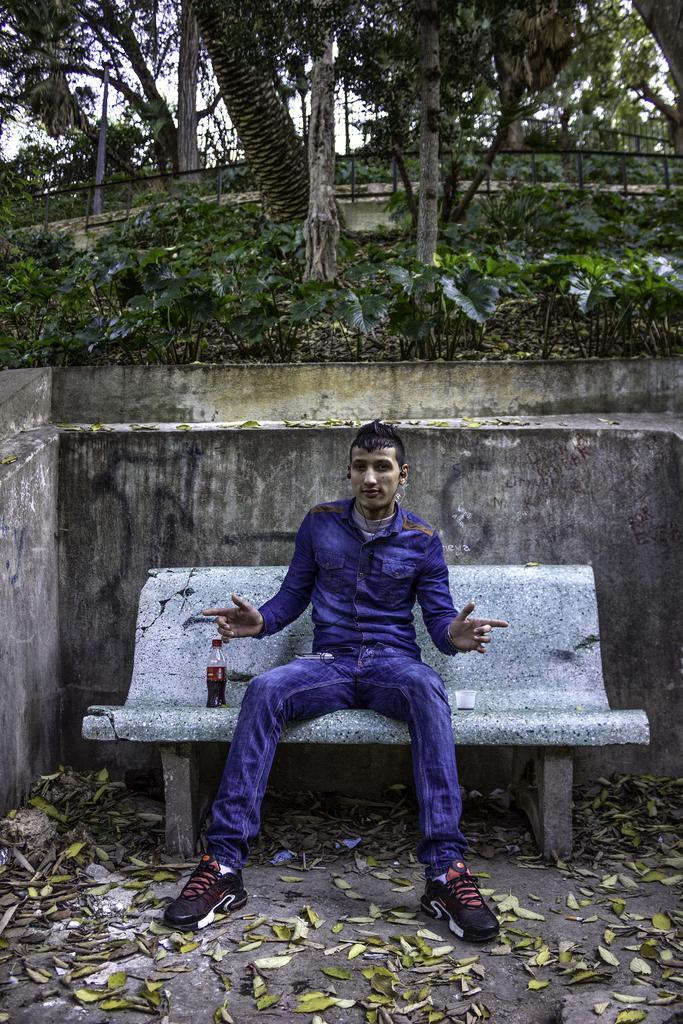How would you summarize this image in a sentence or two? This picture describes about a man seated on the bench, besides him there is a bottle. In the background we can see couple of trees. 